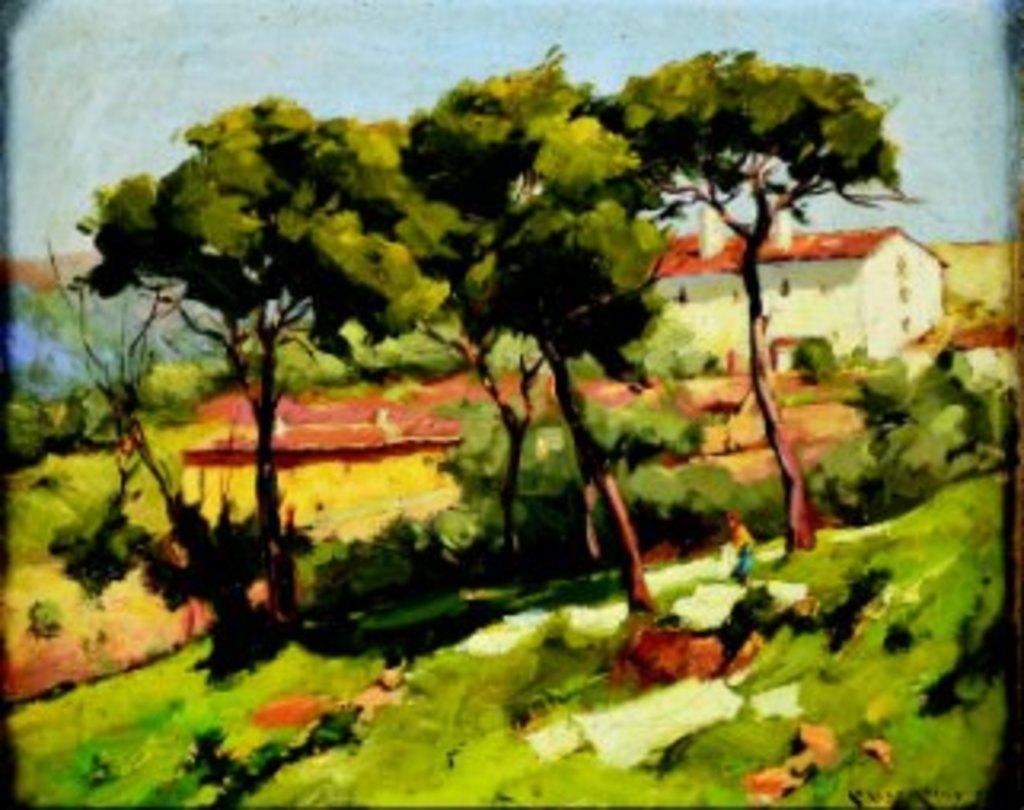Can you describe this image briefly? There is a painting in which, there are trees, plants and grass on the ground. In the background, there is a building which is having windows and roof and there are clouds in the sky. 